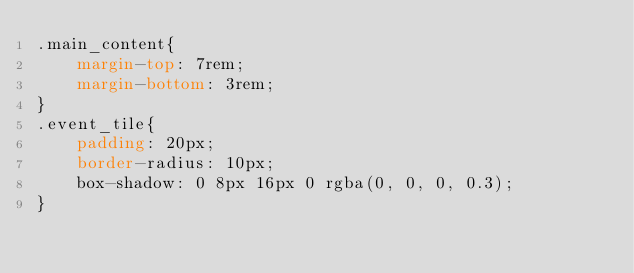Convert code to text. <code><loc_0><loc_0><loc_500><loc_500><_CSS_>.main_content{
    margin-top: 7rem;
    margin-bottom: 3rem;
}
.event_tile{
    padding: 20px;
    border-radius: 10px;
    box-shadow: 0 8px 16px 0 rgba(0, 0, 0, 0.3);
}</code> 